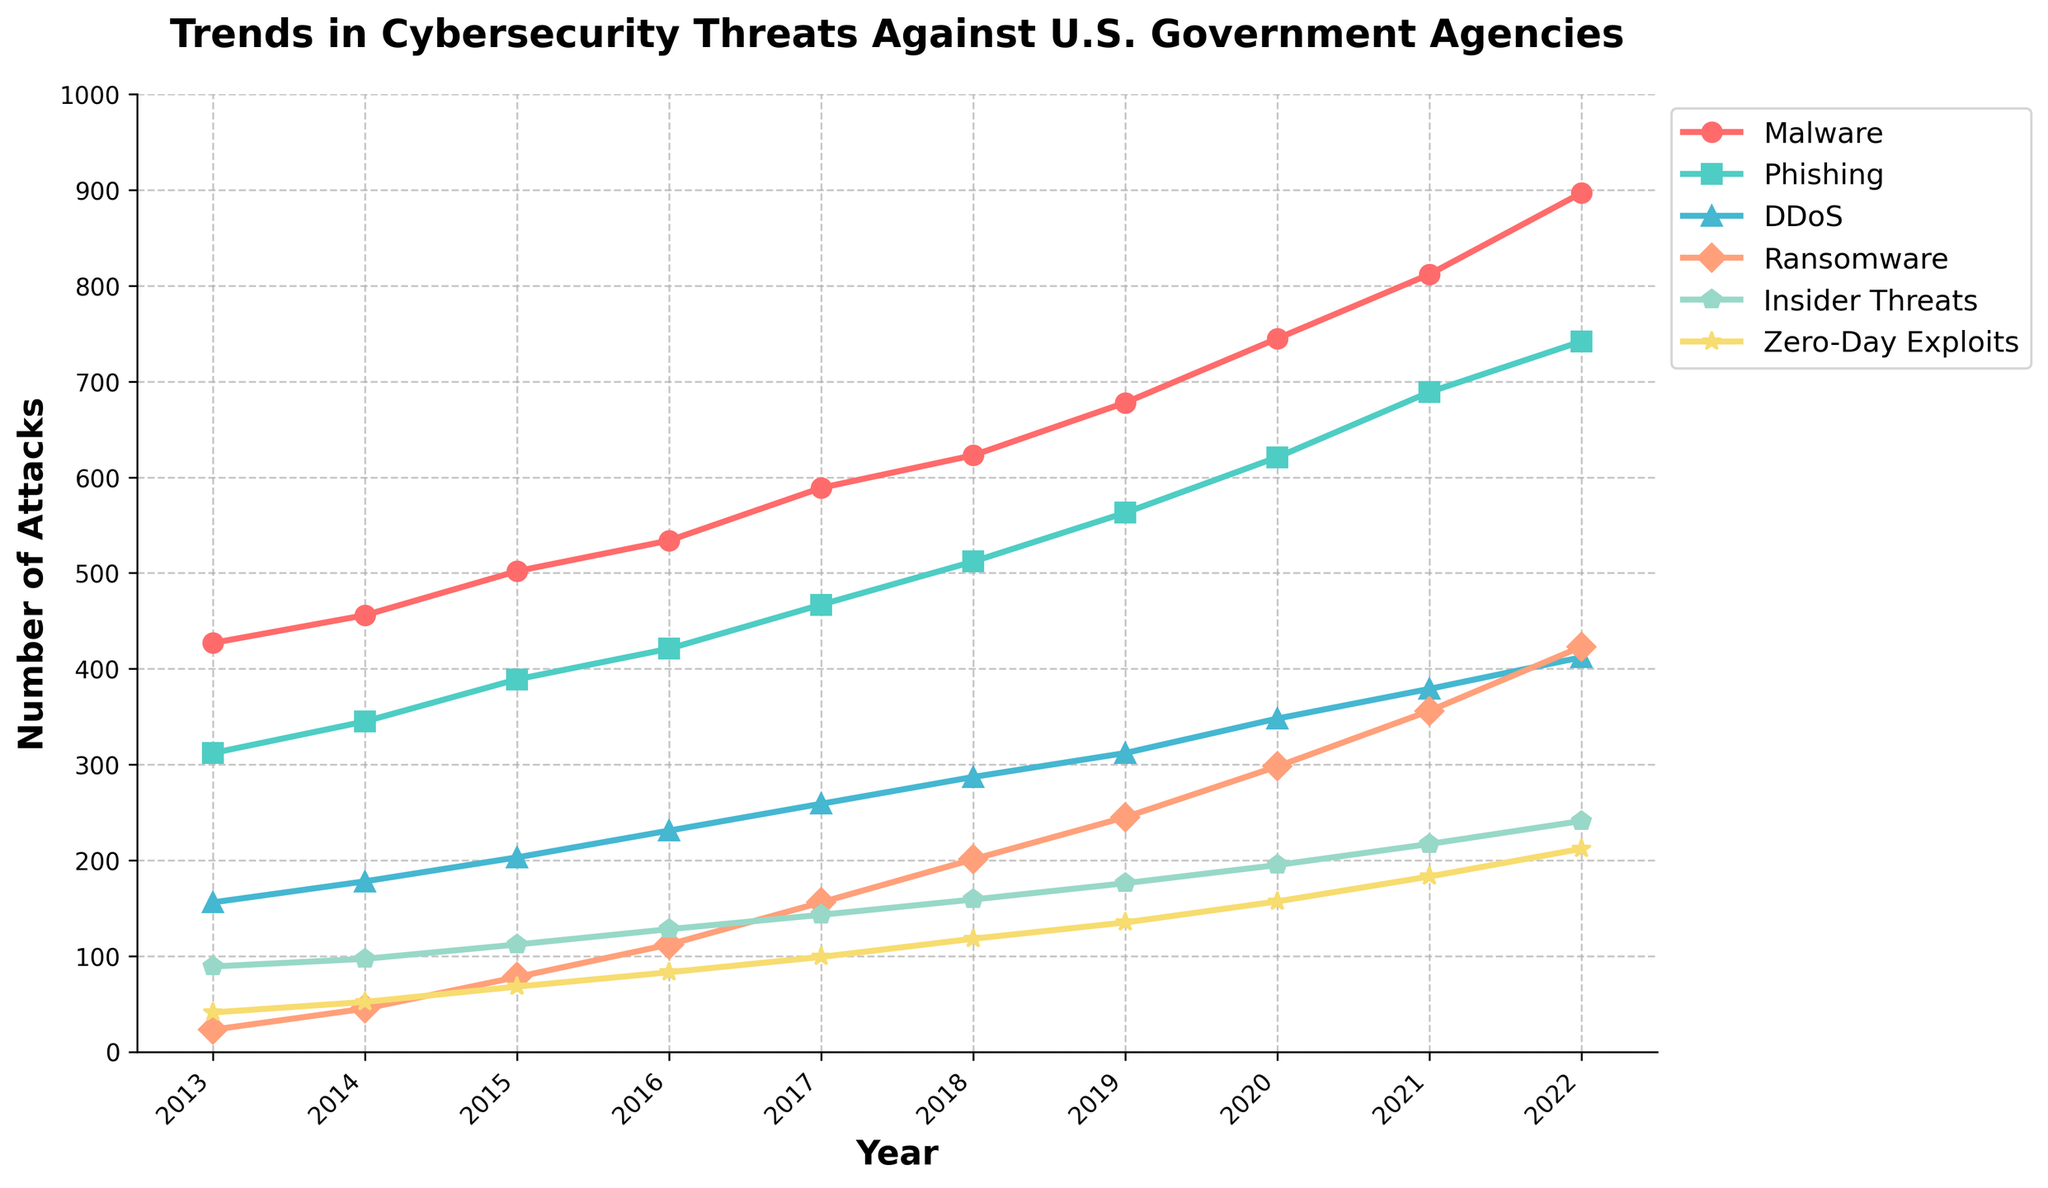Which type of cybersecurity threat saw the highest increase in frequency from 2013 to 2022? Subtract the values of each threat type in 2013 from those in 2022 and compare: Malware (897 - 427 = 470), Phishing (742 - 312 = 430), DDoS (412 - 156 = 256), Ransomware (423 - 23 = 400), Insider Threats (241 - 89 = 152), Zero-Day Exploits (212 - 41 = 171). Malware had the highest increase.
Answer: Malware By how much did ransomware attacks increase from 2016 to 2022? Subtract the number of ransomware attacks in 2016 from the number in 2022: 423 - 112 = 311.
Answer: 311 Which cybersecurity threat type had the smallest overall increase between 2013 and 2022? Subtract the values of each threat type in 2013 from those in 2022 and compare: Malware (470), Phishing (430), DDoS (256), Ransomware (400), Insider Threats (152), Zero-Day Exploits (171). Insider Threats had the smallest increase.
Answer: Insider Threats In what year did the number of zero-day exploits first exceed 100? Observe the trend line for zero-day exploits and identify the first year when it crosses the 100 mark. This occurs in 2016 with a value of 112.
Answer: 2016 Compare the trend of phishing and zero-day exploits. How many more phishing attacks were there than zero-day exploits in 2022? Subtract the number of zero-day exploits from the number of phishing attacks in 2022: 742 - 212 = 530.
Answer: 530 Which type of attack showed a steady increase every year without any decrease? Examine each trend line for Malware, Phishing, DDoS, Ransomware, Insider Threats, and Zero-Day Exploits from 2013 to 2022; identify which ones show consistent increments yearly. All types showed steady increases.
Answer: All What is the total number of DDoS attacks and Insider Threats in 2020? Add the values of DDoS attacks and Insider Threats in 2020: 348 + 195 = 543.
Answer: 543 Which two threat types had nearly the same number of attacks in 2018, and what were those numbers? Compare values for 2018: Malware (623), Phishing (512), DDoS (287), Ransomware (201), Insider Threats (159), Zero-Day Exploits (118). Insider Threats (159) and Zero-Day Exploits (118) were closest.
Answer: Insider Threats (159) and Zero-Day Exploits (118) 